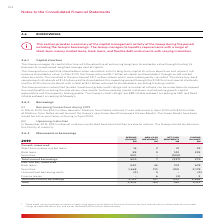According to Woolworths Limited's financial document, How does the Group manage its liquidity requirements? The Group manages its liquidity requirements with a range of short-term money market loans, bank loans, and flexible debt instruments with varying maturities.. The document states: "ring the period, including the Group’s borrowings. The Group manages its liquidity requirements with a range of short-term money market loans, bank lo..." Also, According to S&P, what is the credit rating for the Group? According to the financial document, BBB. The relevant text states: "leasing profile. The Group’s credit ratings 1 are BBB (stable outlook) according to S&P and Baa2 (stable outlook) according to Moody’s...." Also, According to Moody's, what is the credit rating for the Group? According to the financial document, Baa2. The relevant text states: "s 1 are BBB (stable outlook) according to S&P and Baa2 (stable outlook) according to Moody’s...." Also, can you calculate: What is the difference between the total opening balance and the total closing balance? Based on the calculation: 3,129 - 2,803 , the result is 326 (in millions). This is based on the information: "non‑current borrowings 2,199 157 499 2,855 Total 2,803 164 162 3,129 orrowings 2,199 157 499 2,855 Total 2,803 164 162 3,129..." The key data points involved are: 2,803, 3,129. Also, can you calculate: What percentage constitution does total non-current borrowings hold in the total opening balance? Based on the calculation: 2,199/2,803 , the result is 78.45 (percentage). This is based on the information: "nce leases – 6 (3) 3 Total non‑current borrowings 2,199 157 499 2,855 Total 2,803 164 162 3,129 non‑current borrowings 2,199 157 499 2,855 Total 2,803 164 162 3,129..." The key data points involved are: 2,199, 2,803. Also, can you calculate: What percentage constitution does bank loans hold in total non-current borrowings in the closing balance? Based on the calculation: 678/2,855 , the result is 23.75 (percentage). This is based on the information: "274 Non‑current, unsecured Bank loans 540 36 102 678 Securities 1,668 110 400 2,178 Unamortised borrowing costs (9) 5 – (4) Finance leases – 6 (3) 3 Tot (3) 3 Total non‑current borrowings 2,199 157 49..." The key data points involved are: 2,855, 678. 